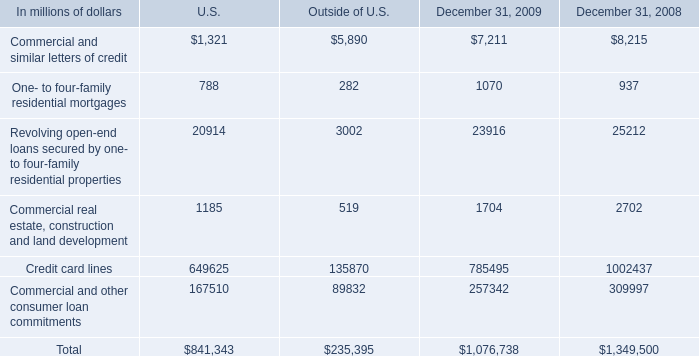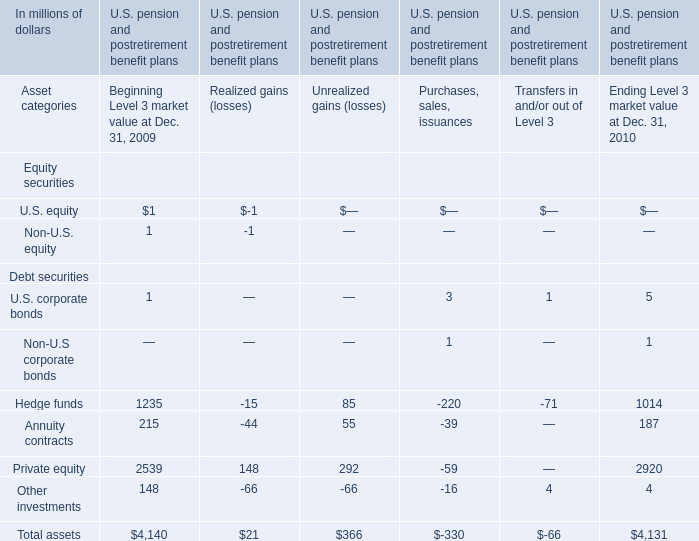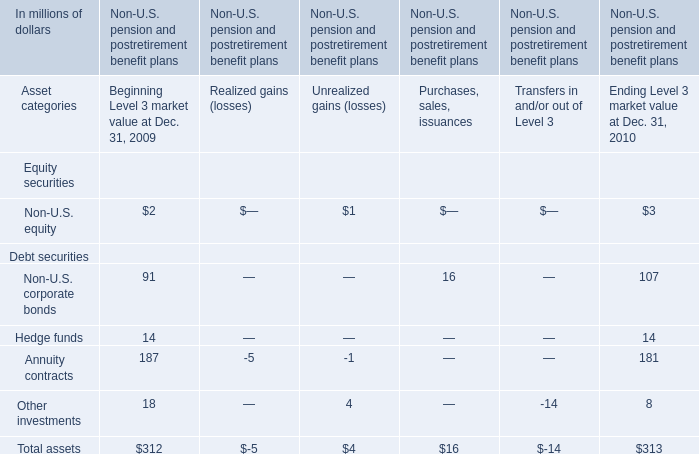What is the sum of Hedge funds for Unrealized gains (losses) in Table 1 and Non-U.S. corporate bonds for Purchases, sales, issuances in Table 2? (in million) 
Computations: (85 + 16)
Answer: 101.0. At Dec. 31 of which year is Total assets as Level 3 market value the most? 
Answer: 2010. 